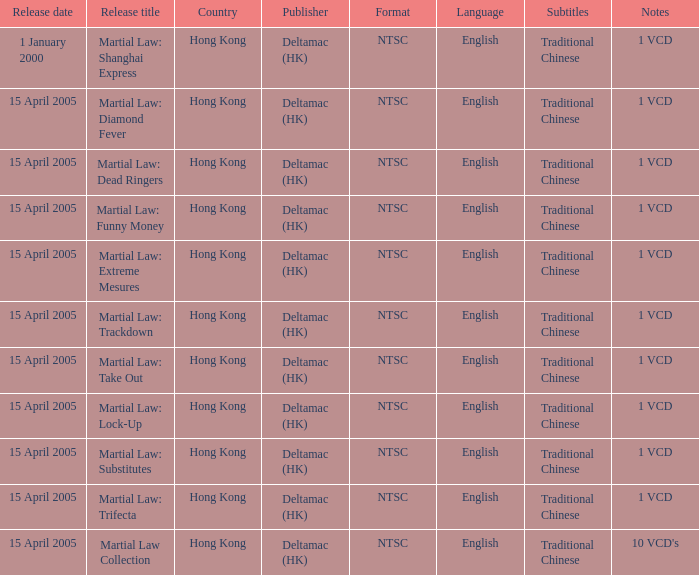Martial law: substitutes was released by which publisher? Deltamac (HK). 